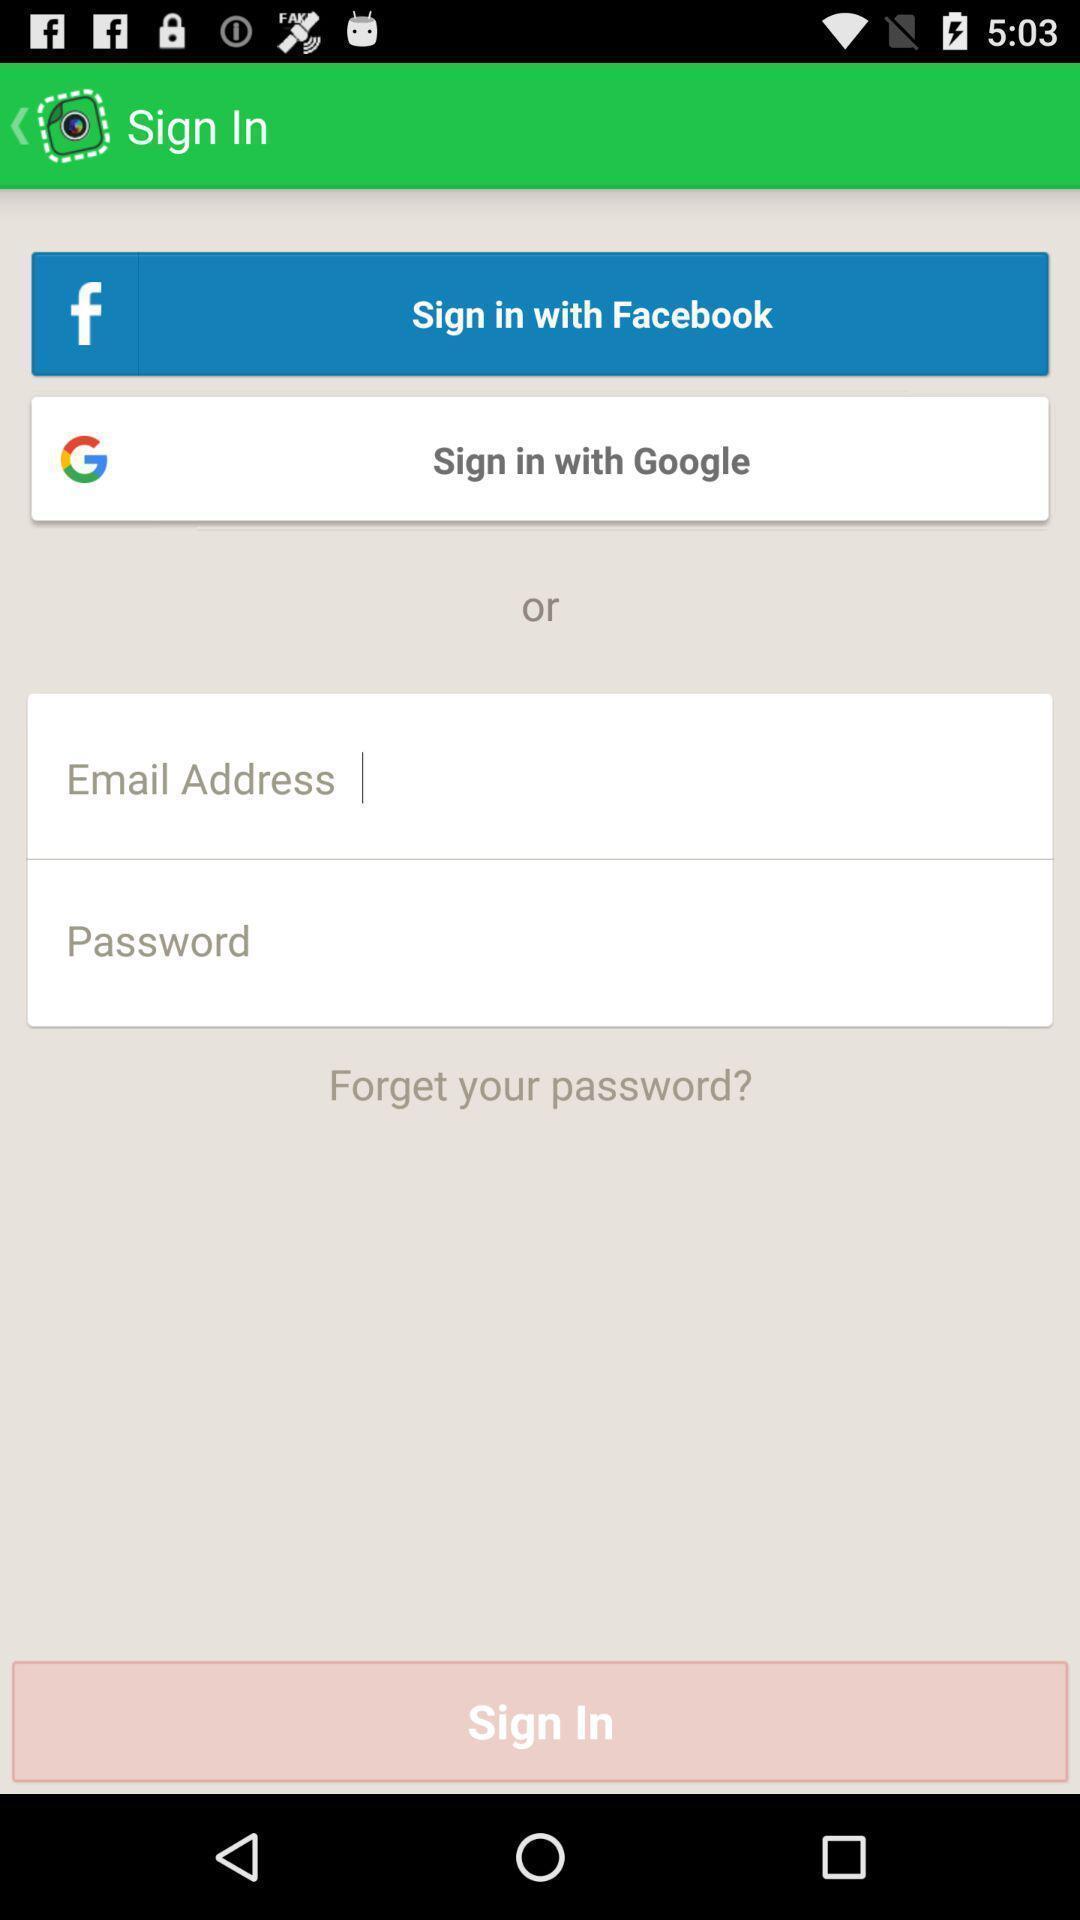Provide a description of this screenshot. Welcome to the sign in page. 